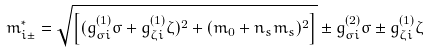Convert formula to latex. <formula><loc_0><loc_0><loc_500><loc_500>m ^ { * } _ { i \pm } = \sqrt { \left [ ( g ^ { ( 1 ) } _ { \sigma i } \sigma + g ^ { ( 1 ) } _ { \zeta i } \zeta ) ^ { 2 } + ( m _ { 0 } + n _ { s } m _ { s } ) ^ { 2 } \right ] } \pm g ^ { ( 2 ) } _ { \sigma i } \sigma \pm g ^ { ( 1 ) } _ { \zeta i } \zeta</formula> 